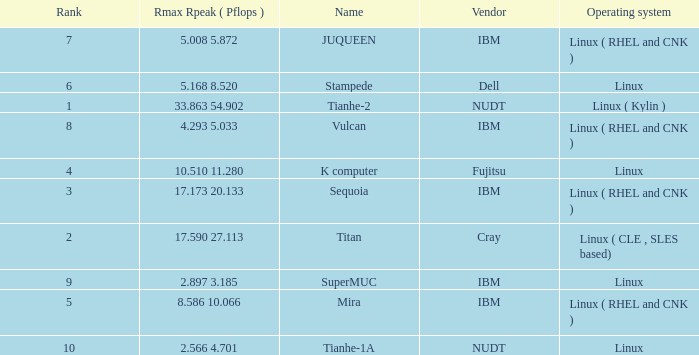What is the name of Rank 5? Mira. 